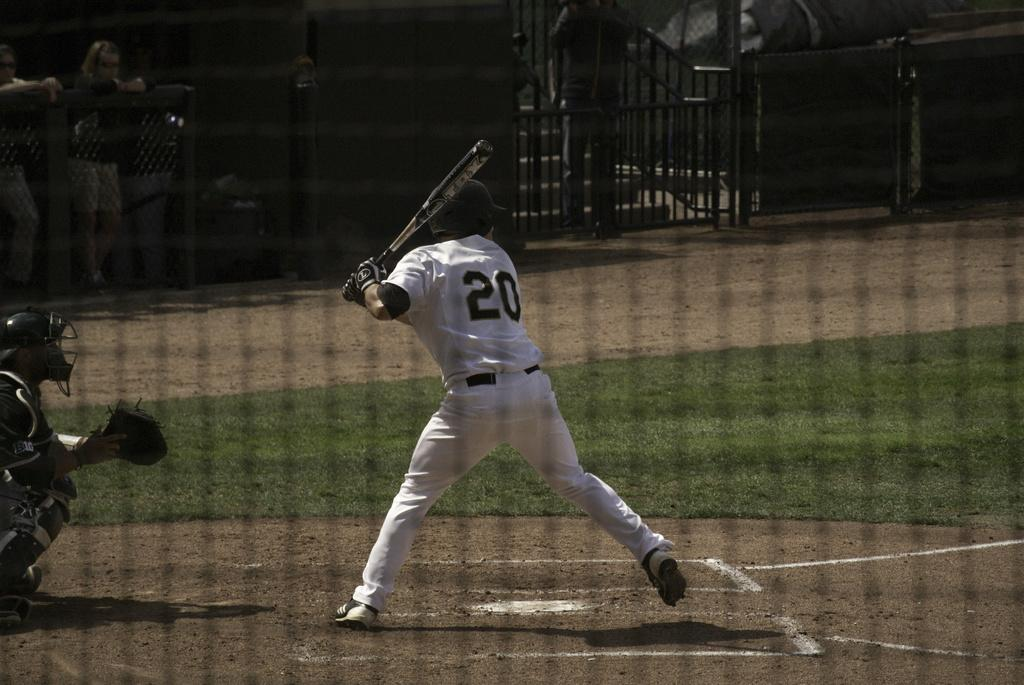<image>
Provide a brief description of the given image. A baseball player wearing number 20 begins to swing at a pitch at the plate. 